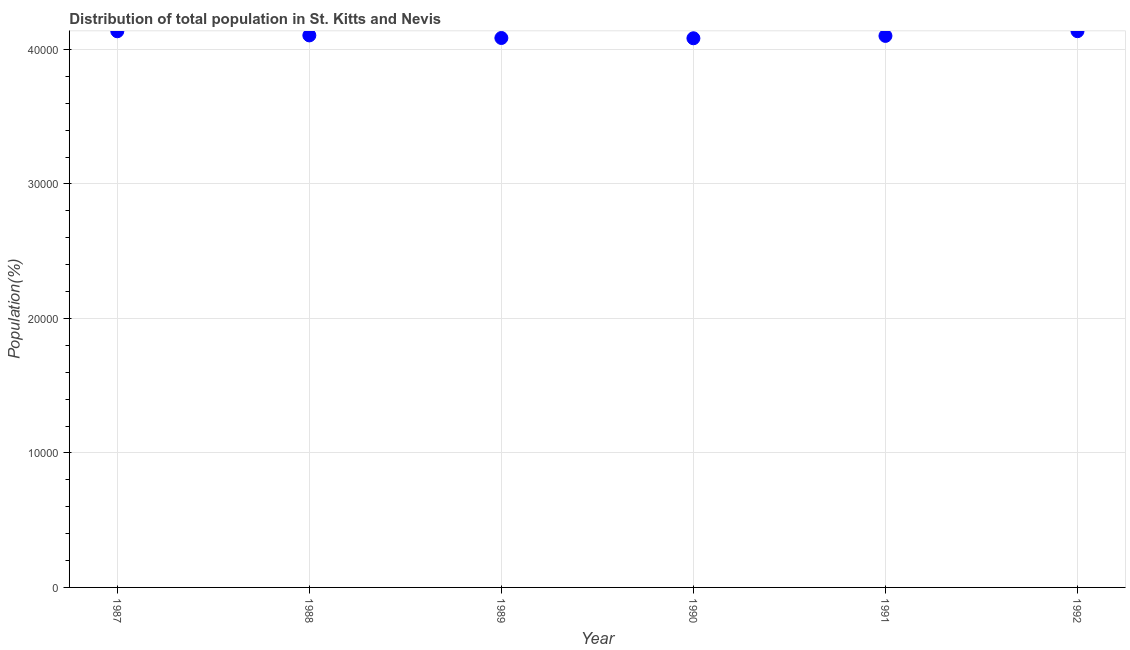What is the population in 1987?
Ensure brevity in your answer.  4.14e+04. Across all years, what is the maximum population?
Ensure brevity in your answer.  4.14e+04. Across all years, what is the minimum population?
Your response must be concise. 4.08e+04. In which year was the population maximum?
Offer a very short reply. 1992. In which year was the population minimum?
Ensure brevity in your answer.  1990. What is the sum of the population?
Offer a very short reply. 2.46e+05. What is the difference between the population in 1987 and 1992?
Provide a short and direct response. -7. What is the average population per year?
Ensure brevity in your answer.  4.11e+04. What is the median population?
Provide a short and direct response. 4.10e+04. Do a majority of the years between 1988 and 1990 (inclusive) have population greater than 34000 %?
Keep it short and to the point. Yes. What is the ratio of the population in 1989 to that in 1992?
Provide a succinct answer. 0.99. Is the difference between the population in 1987 and 1990 greater than the difference between any two years?
Keep it short and to the point. No. What is the difference between the highest and the second highest population?
Provide a short and direct response. 7. What is the difference between the highest and the lowest population?
Make the answer very short. 527. In how many years, is the population greater than the average population taken over all years?
Offer a terse response. 2. What is the difference between two consecutive major ticks on the Y-axis?
Your response must be concise. 10000. Does the graph contain any zero values?
Provide a succinct answer. No. Does the graph contain grids?
Give a very brief answer. Yes. What is the title of the graph?
Ensure brevity in your answer.  Distribution of total population in St. Kitts and Nevis . What is the label or title of the Y-axis?
Give a very brief answer. Population(%). What is the Population(%) in 1987?
Your response must be concise. 4.14e+04. What is the Population(%) in 1988?
Offer a very short reply. 4.10e+04. What is the Population(%) in 1989?
Provide a succinct answer. 4.09e+04. What is the Population(%) in 1990?
Your response must be concise. 4.08e+04. What is the Population(%) in 1991?
Keep it short and to the point. 4.10e+04. What is the Population(%) in 1992?
Give a very brief answer. 4.14e+04. What is the difference between the Population(%) in 1987 and 1988?
Your answer should be very brief. 308. What is the difference between the Population(%) in 1987 and 1989?
Make the answer very short. 499. What is the difference between the Population(%) in 1987 and 1990?
Keep it short and to the point. 520. What is the difference between the Population(%) in 1987 and 1991?
Your answer should be compact. 344. What is the difference between the Population(%) in 1988 and 1989?
Provide a succinct answer. 191. What is the difference between the Population(%) in 1988 and 1990?
Offer a terse response. 212. What is the difference between the Population(%) in 1988 and 1991?
Give a very brief answer. 36. What is the difference between the Population(%) in 1988 and 1992?
Provide a short and direct response. -315. What is the difference between the Population(%) in 1989 and 1990?
Your answer should be compact. 21. What is the difference between the Population(%) in 1989 and 1991?
Ensure brevity in your answer.  -155. What is the difference between the Population(%) in 1989 and 1992?
Your answer should be compact. -506. What is the difference between the Population(%) in 1990 and 1991?
Make the answer very short. -176. What is the difference between the Population(%) in 1990 and 1992?
Your answer should be compact. -527. What is the difference between the Population(%) in 1991 and 1992?
Keep it short and to the point. -351. What is the ratio of the Population(%) in 1987 to that in 1988?
Provide a succinct answer. 1.01. What is the ratio of the Population(%) in 1987 to that in 1989?
Make the answer very short. 1.01. What is the ratio of the Population(%) in 1987 to that in 1991?
Your answer should be compact. 1.01. What is the ratio of the Population(%) in 1987 to that in 1992?
Ensure brevity in your answer.  1. What is the ratio of the Population(%) in 1988 to that in 1989?
Provide a short and direct response. 1. What is the ratio of the Population(%) in 1988 to that in 1991?
Offer a terse response. 1. What is the ratio of the Population(%) in 1988 to that in 1992?
Your response must be concise. 0.99. What is the ratio of the Population(%) in 1989 to that in 1990?
Provide a short and direct response. 1. What is the ratio of the Population(%) in 1989 to that in 1991?
Provide a short and direct response. 1. What is the ratio of the Population(%) in 1990 to that in 1991?
Provide a succinct answer. 1. What is the ratio of the Population(%) in 1990 to that in 1992?
Keep it short and to the point. 0.99. What is the ratio of the Population(%) in 1991 to that in 1992?
Offer a very short reply. 0.99. 